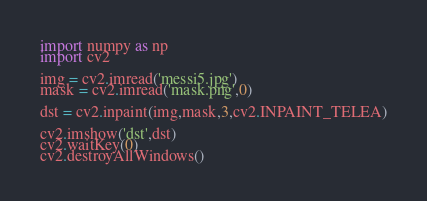<code> <loc_0><loc_0><loc_500><loc_500><_Python_>import numpy as np
import cv2

img = cv2.imread('messi5.jpg')
mask = cv2.imread('mask.png',0)

dst = cv2.inpaint(img,mask,3,cv2.INPAINT_TELEA)

cv2.imshow('dst',dst)
cv2.waitKey(0)
cv2.destroyAllWindows()
</code> 